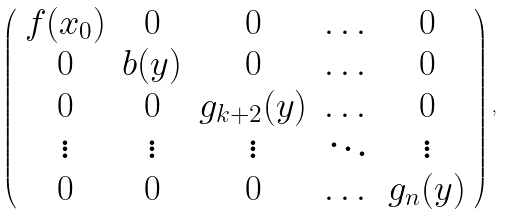Convert formula to latex. <formula><loc_0><loc_0><loc_500><loc_500>\left ( \begin{array} { c c c c c } f ( x _ { 0 } ) & 0 & 0 & \dots & 0 \\ 0 & b ( y ) & 0 & \dots & 0 \\ 0 & 0 & g _ { k + 2 } ( y ) & \dots & 0 \\ \vdots & \vdots & \vdots & \ddots & \vdots \\ 0 & 0 & 0 & \dots & g _ { n } ( y ) \end{array} \right ) ,</formula> 